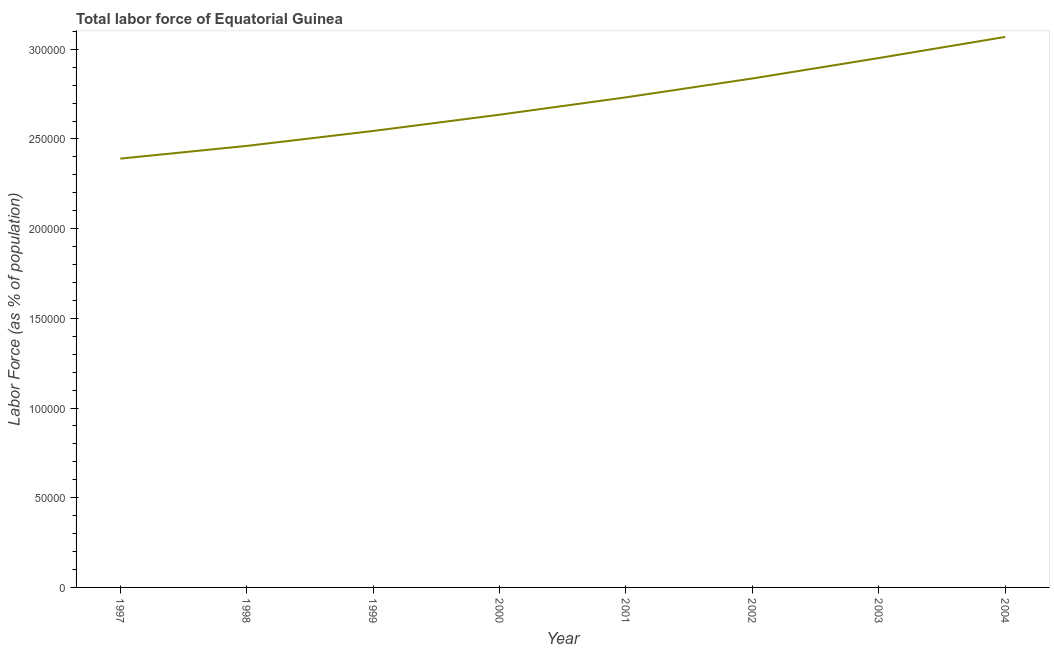What is the total labor force in 1998?
Your answer should be compact. 2.46e+05. Across all years, what is the maximum total labor force?
Keep it short and to the point. 3.07e+05. Across all years, what is the minimum total labor force?
Keep it short and to the point. 2.39e+05. What is the sum of the total labor force?
Offer a very short reply. 2.16e+06. What is the difference between the total labor force in 1997 and 2003?
Your response must be concise. -5.61e+04. What is the average total labor force per year?
Offer a terse response. 2.70e+05. What is the median total labor force?
Provide a short and direct response. 2.68e+05. Do a majority of the years between 2004 and 2002 (inclusive) have total labor force greater than 60000 %?
Offer a terse response. No. What is the ratio of the total labor force in 1997 to that in 1999?
Your answer should be very brief. 0.94. Is the total labor force in 2000 less than that in 2001?
Provide a succinct answer. Yes. Is the difference between the total labor force in 1998 and 2004 greater than the difference between any two years?
Provide a short and direct response. No. What is the difference between the highest and the second highest total labor force?
Keep it short and to the point. 1.18e+04. Is the sum of the total labor force in 1997 and 2001 greater than the maximum total labor force across all years?
Your response must be concise. Yes. What is the difference between the highest and the lowest total labor force?
Keep it short and to the point. 6.79e+04. In how many years, is the total labor force greater than the average total labor force taken over all years?
Provide a succinct answer. 4. How many lines are there?
Your answer should be very brief. 1. How many years are there in the graph?
Keep it short and to the point. 8. What is the difference between two consecutive major ticks on the Y-axis?
Provide a succinct answer. 5.00e+04. Does the graph contain any zero values?
Give a very brief answer. No. Does the graph contain grids?
Give a very brief answer. No. What is the title of the graph?
Provide a short and direct response. Total labor force of Equatorial Guinea. What is the label or title of the Y-axis?
Offer a very short reply. Labor Force (as % of population). What is the Labor Force (as % of population) of 1997?
Your response must be concise. 2.39e+05. What is the Labor Force (as % of population) of 1998?
Your answer should be very brief. 2.46e+05. What is the Labor Force (as % of population) in 1999?
Your response must be concise. 2.54e+05. What is the Labor Force (as % of population) of 2000?
Provide a succinct answer. 2.64e+05. What is the Labor Force (as % of population) of 2001?
Your answer should be compact. 2.73e+05. What is the Labor Force (as % of population) in 2002?
Make the answer very short. 2.84e+05. What is the Labor Force (as % of population) in 2003?
Provide a short and direct response. 2.95e+05. What is the Labor Force (as % of population) of 2004?
Provide a succinct answer. 3.07e+05. What is the difference between the Labor Force (as % of population) in 1997 and 1998?
Ensure brevity in your answer.  -7088. What is the difference between the Labor Force (as % of population) in 1997 and 1999?
Ensure brevity in your answer.  -1.54e+04. What is the difference between the Labor Force (as % of population) in 1997 and 2000?
Your answer should be compact. -2.45e+04. What is the difference between the Labor Force (as % of population) in 1997 and 2001?
Keep it short and to the point. -3.42e+04. What is the difference between the Labor Force (as % of population) in 1997 and 2002?
Your answer should be compact. -4.47e+04. What is the difference between the Labor Force (as % of population) in 1997 and 2003?
Offer a very short reply. -5.61e+04. What is the difference between the Labor Force (as % of population) in 1997 and 2004?
Your response must be concise. -6.79e+04. What is the difference between the Labor Force (as % of population) in 1998 and 1999?
Make the answer very short. -8333. What is the difference between the Labor Force (as % of population) in 1998 and 2000?
Offer a terse response. -1.74e+04. What is the difference between the Labor Force (as % of population) in 1998 and 2001?
Ensure brevity in your answer.  -2.71e+04. What is the difference between the Labor Force (as % of population) in 1998 and 2002?
Provide a succinct answer. -3.76e+04. What is the difference between the Labor Force (as % of population) in 1998 and 2003?
Provide a succinct answer. -4.90e+04. What is the difference between the Labor Force (as % of population) in 1998 and 2004?
Provide a short and direct response. -6.08e+04. What is the difference between the Labor Force (as % of population) in 1999 and 2000?
Provide a succinct answer. -9071. What is the difference between the Labor Force (as % of population) in 1999 and 2001?
Ensure brevity in your answer.  -1.87e+04. What is the difference between the Labor Force (as % of population) in 1999 and 2002?
Provide a short and direct response. -2.93e+04. What is the difference between the Labor Force (as % of population) in 1999 and 2003?
Offer a very short reply. -4.07e+04. What is the difference between the Labor Force (as % of population) in 1999 and 2004?
Your answer should be compact. -5.24e+04. What is the difference between the Labor Force (as % of population) in 2000 and 2001?
Your response must be concise. -9671. What is the difference between the Labor Force (as % of population) in 2000 and 2002?
Provide a succinct answer. -2.02e+04. What is the difference between the Labor Force (as % of population) in 2000 and 2003?
Ensure brevity in your answer.  -3.16e+04. What is the difference between the Labor Force (as % of population) in 2000 and 2004?
Offer a very short reply. -4.34e+04. What is the difference between the Labor Force (as % of population) in 2001 and 2002?
Ensure brevity in your answer.  -1.05e+04. What is the difference between the Labor Force (as % of population) in 2001 and 2003?
Your answer should be very brief. -2.19e+04. What is the difference between the Labor Force (as % of population) in 2001 and 2004?
Give a very brief answer. -3.37e+04. What is the difference between the Labor Force (as % of population) in 2002 and 2003?
Keep it short and to the point. -1.14e+04. What is the difference between the Labor Force (as % of population) in 2002 and 2004?
Give a very brief answer. -2.32e+04. What is the difference between the Labor Force (as % of population) in 2003 and 2004?
Provide a short and direct response. -1.18e+04. What is the ratio of the Labor Force (as % of population) in 1997 to that in 1998?
Your answer should be very brief. 0.97. What is the ratio of the Labor Force (as % of population) in 1997 to that in 1999?
Keep it short and to the point. 0.94. What is the ratio of the Labor Force (as % of population) in 1997 to that in 2000?
Offer a terse response. 0.91. What is the ratio of the Labor Force (as % of population) in 1997 to that in 2001?
Your response must be concise. 0.88. What is the ratio of the Labor Force (as % of population) in 1997 to that in 2002?
Your response must be concise. 0.84. What is the ratio of the Labor Force (as % of population) in 1997 to that in 2003?
Your answer should be compact. 0.81. What is the ratio of the Labor Force (as % of population) in 1997 to that in 2004?
Give a very brief answer. 0.78. What is the ratio of the Labor Force (as % of population) in 1998 to that in 1999?
Ensure brevity in your answer.  0.97. What is the ratio of the Labor Force (as % of population) in 1998 to that in 2000?
Your response must be concise. 0.93. What is the ratio of the Labor Force (as % of population) in 1998 to that in 2001?
Keep it short and to the point. 0.9. What is the ratio of the Labor Force (as % of population) in 1998 to that in 2002?
Provide a succinct answer. 0.87. What is the ratio of the Labor Force (as % of population) in 1998 to that in 2003?
Make the answer very short. 0.83. What is the ratio of the Labor Force (as % of population) in 1998 to that in 2004?
Your answer should be very brief. 0.8. What is the ratio of the Labor Force (as % of population) in 1999 to that in 2000?
Offer a terse response. 0.97. What is the ratio of the Labor Force (as % of population) in 1999 to that in 2002?
Provide a short and direct response. 0.9. What is the ratio of the Labor Force (as % of population) in 1999 to that in 2003?
Offer a very short reply. 0.86. What is the ratio of the Labor Force (as % of population) in 1999 to that in 2004?
Give a very brief answer. 0.83. What is the ratio of the Labor Force (as % of population) in 2000 to that in 2002?
Provide a short and direct response. 0.93. What is the ratio of the Labor Force (as % of population) in 2000 to that in 2003?
Your response must be concise. 0.89. What is the ratio of the Labor Force (as % of population) in 2000 to that in 2004?
Keep it short and to the point. 0.86. What is the ratio of the Labor Force (as % of population) in 2001 to that in 2002?
Offer a very short reply. 0.96. What is the ratio of the Labor Force (as % of population) in 2001 to that in 2003?
Give a very brief answer. 0.93. What is the ratio of the Labor Force (as % of population) in 2001 to that in 2004?
Your answer should be very brief. 0.89. What is the ratio of the Labor Force (as % of population) in 2002 to that in 2004?
Your response must be concise. 0.93. What is the ratio of the Labor Force (as % of population) in 2003 to that in 2004?
Give a very brief answer. 0.96. 